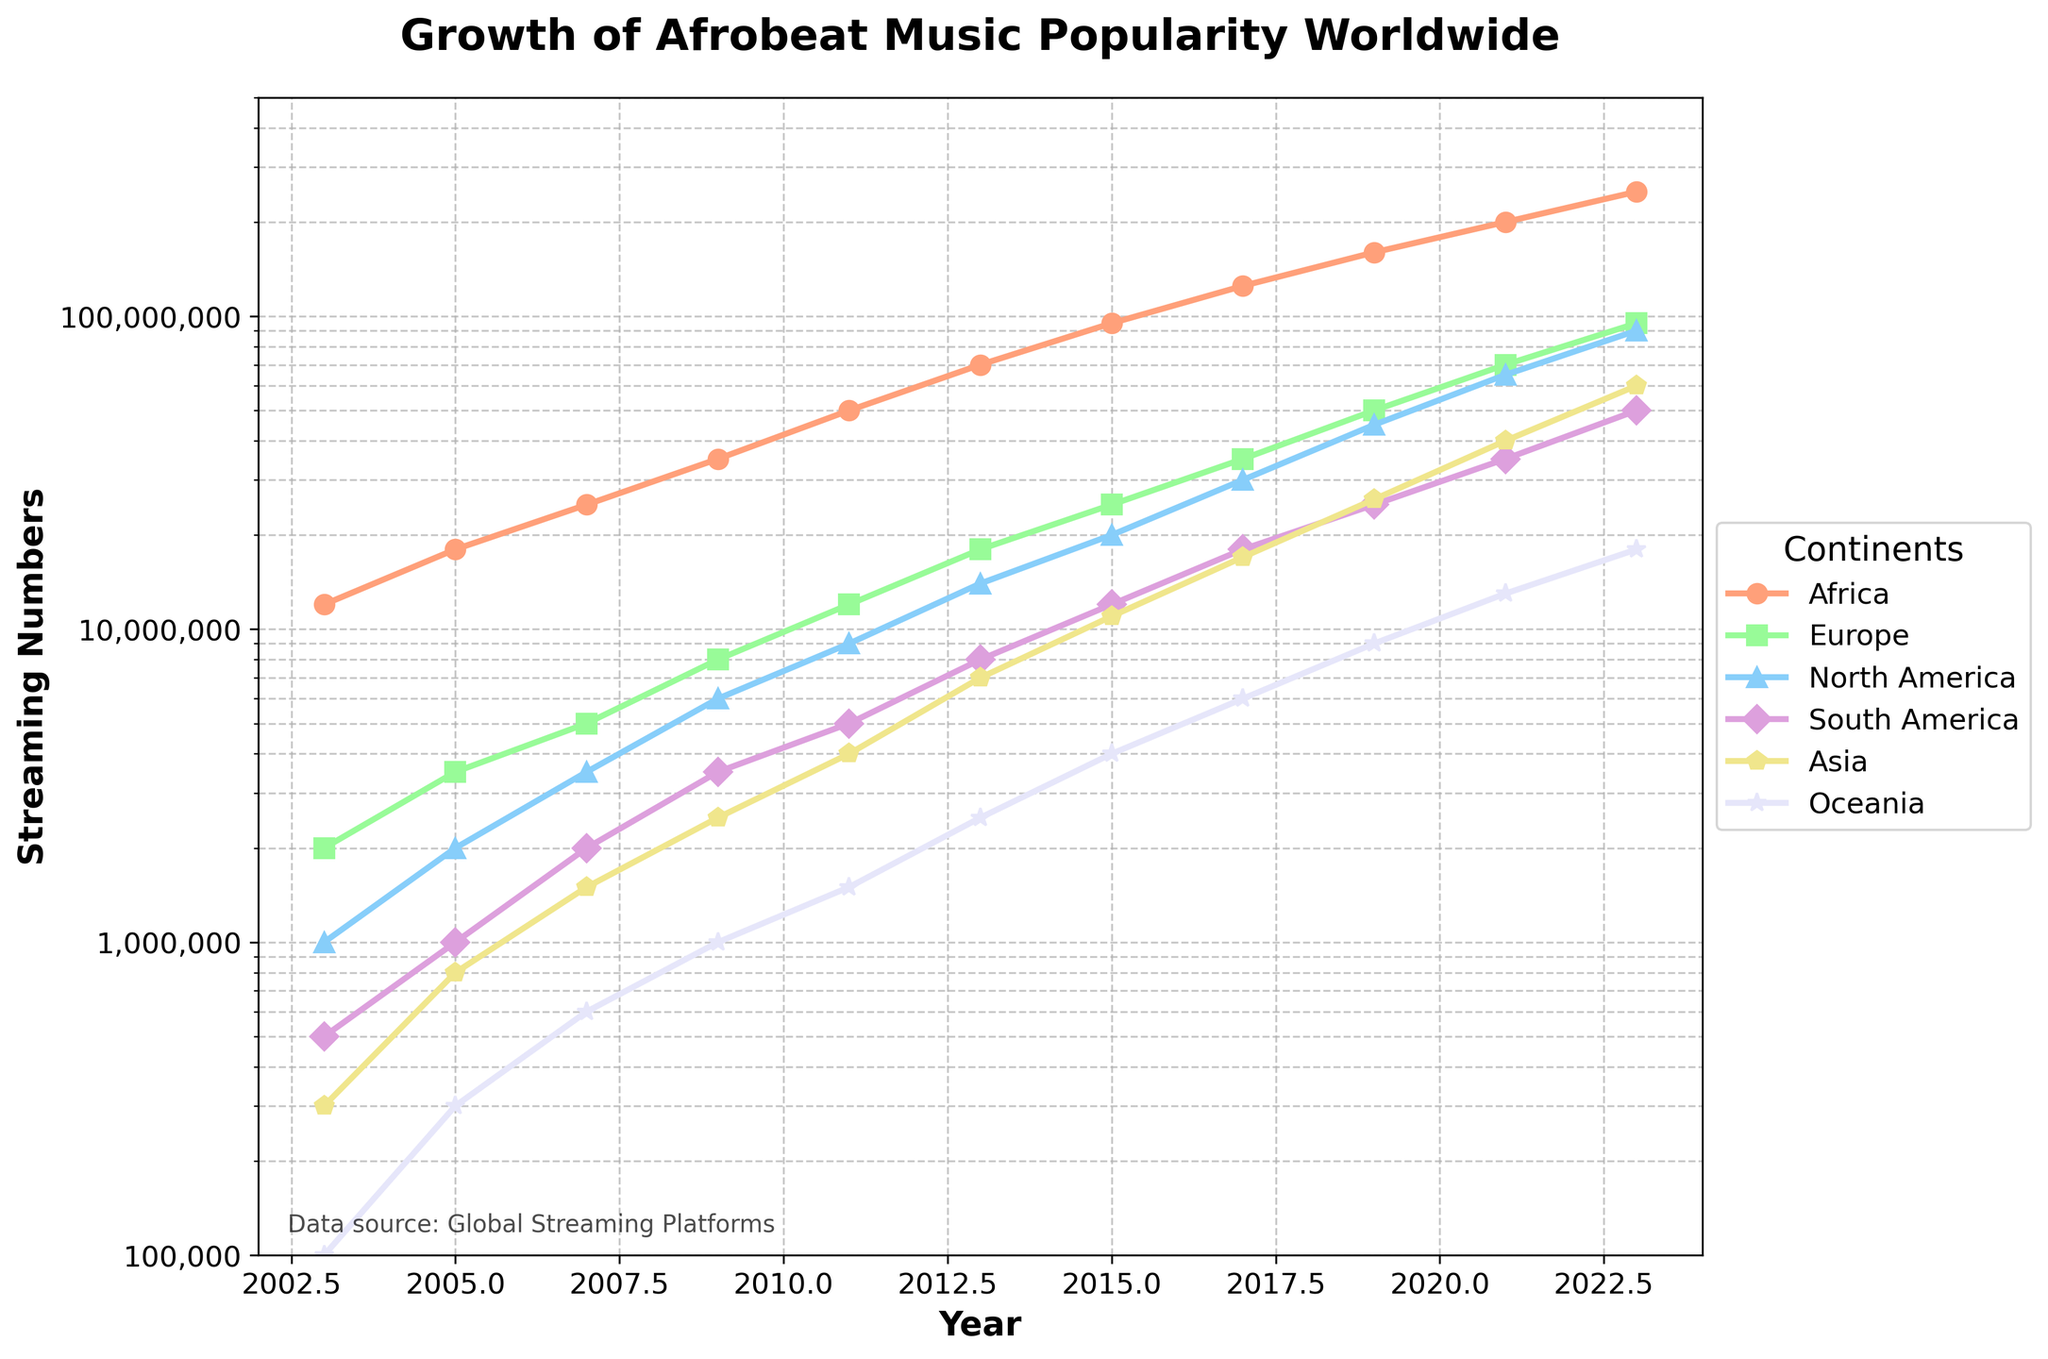What continent had the highest streaming numbers in 2023? Looking at the data for 2023, the continent with the highest streaming numbers is Africa with 250,000,000 streams.
Answer: Africa What is the average streaming number for Afrobeat music in Asia from 2003 to 2023? Summing up the streaming numbers for Asia (300,000 + 800,000 + 1,500,000 + 2,500,000 + 4,000,000 + 7,000,000 + 11,000,000 + 17,000,000 + 26,000,000 + 40,000,000 + 60,000,000) and dividing by the number of years (11), we get (170,400,000 / 11) ≈ 15,490,909.
Answer: Around 15,490,909 Which two continents showed a significant jump in Afrobeat streaming numbers from 2019 to 2021? By checking the difference in streaming numbers from 2019 to 2021, Africa increased from 160,000,000 to 200,000,000 and Asia from 26,000,000 to 40,000,000, which are notable jumps.
Answer: Africa, Asia In which year did Europe surpass 50,000,000 streaming numbers for the first time? By examining the data, Europe hits more than 50,000,000 streams for the first time in 2019.
Answer: 2019 How many continents had streaming numbers above 50,000,000 in 2023? By looking at the data for 2023, continents with more than 50,000,000 streams are Africa, Europe, North America, Asia, making it 4 continents.
Answer: 4 Compare the growth of streaming numbers in Oceania and South America from 2011 to 2019. Which continent grew more, and by how much? Oceania's streaming numbers grew from 1,500,000 in 2011 to 9,000,000 in 2019, an increase of 7,500,000. South America's numbers grew from 5,000,000 to 25,000,000, an increase of 20,000,000. South America grew more by 12,500,000.
Answer: South America, 12,500,000 What can be said about the pattern of Afrobeat music popularity in Africa compared to other continents over the 20 years? The streaming numbers in Africa show a steep, continuous rise over 20 years, significantly higher compared to other continents which also grew but at a comparatively slower rate.
Answer: Steep continuous rise in Africa In what year did all continents collectively surpass 100,000,000 streaming numbers? Summing the stream numbers for all continents, we see that in 2009, the total was 53,500,000 but in 2011 it reaches 86,500,000. Finally, in 2013, it exceeds 100,000,000 (141,500,000).
Answer: 2013 